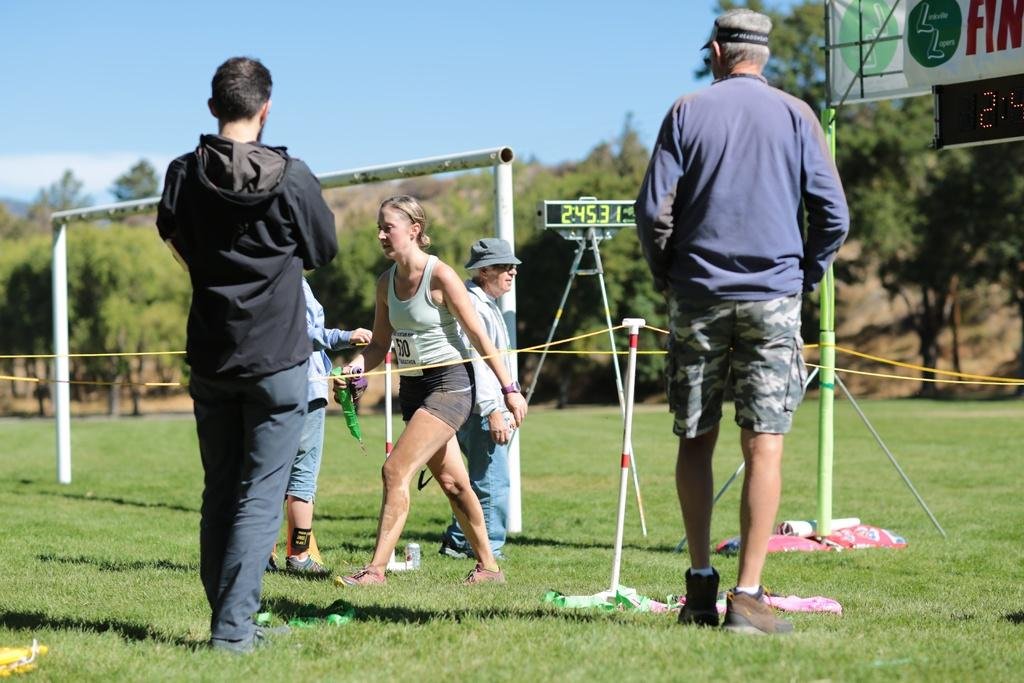Provide a one-sentence caption for the provided image. Several people in a field of a sporting event with a scoreboard with the numbers 24531 litup. 